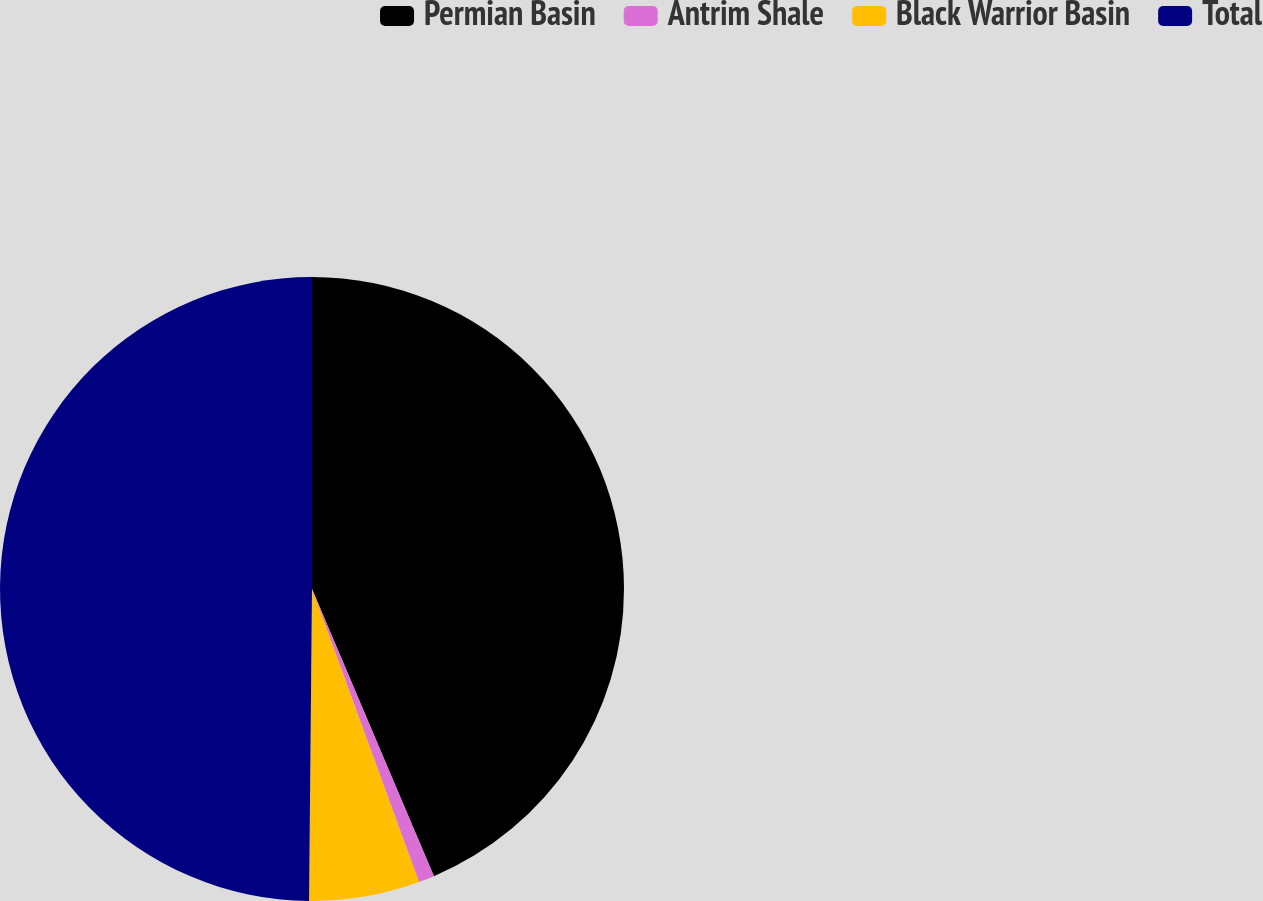<chart> <loc_0><loc_0><loc_500><loc_500><pie_chart><fcel>Permian Basin<fcel>Antrim Shale<fcel>Black Warrior Basin<fcel>Total<nl><fcel>43.61%<fcel>0.82%<fcel>5.72%<fcel>49.85%<nl></chart> 